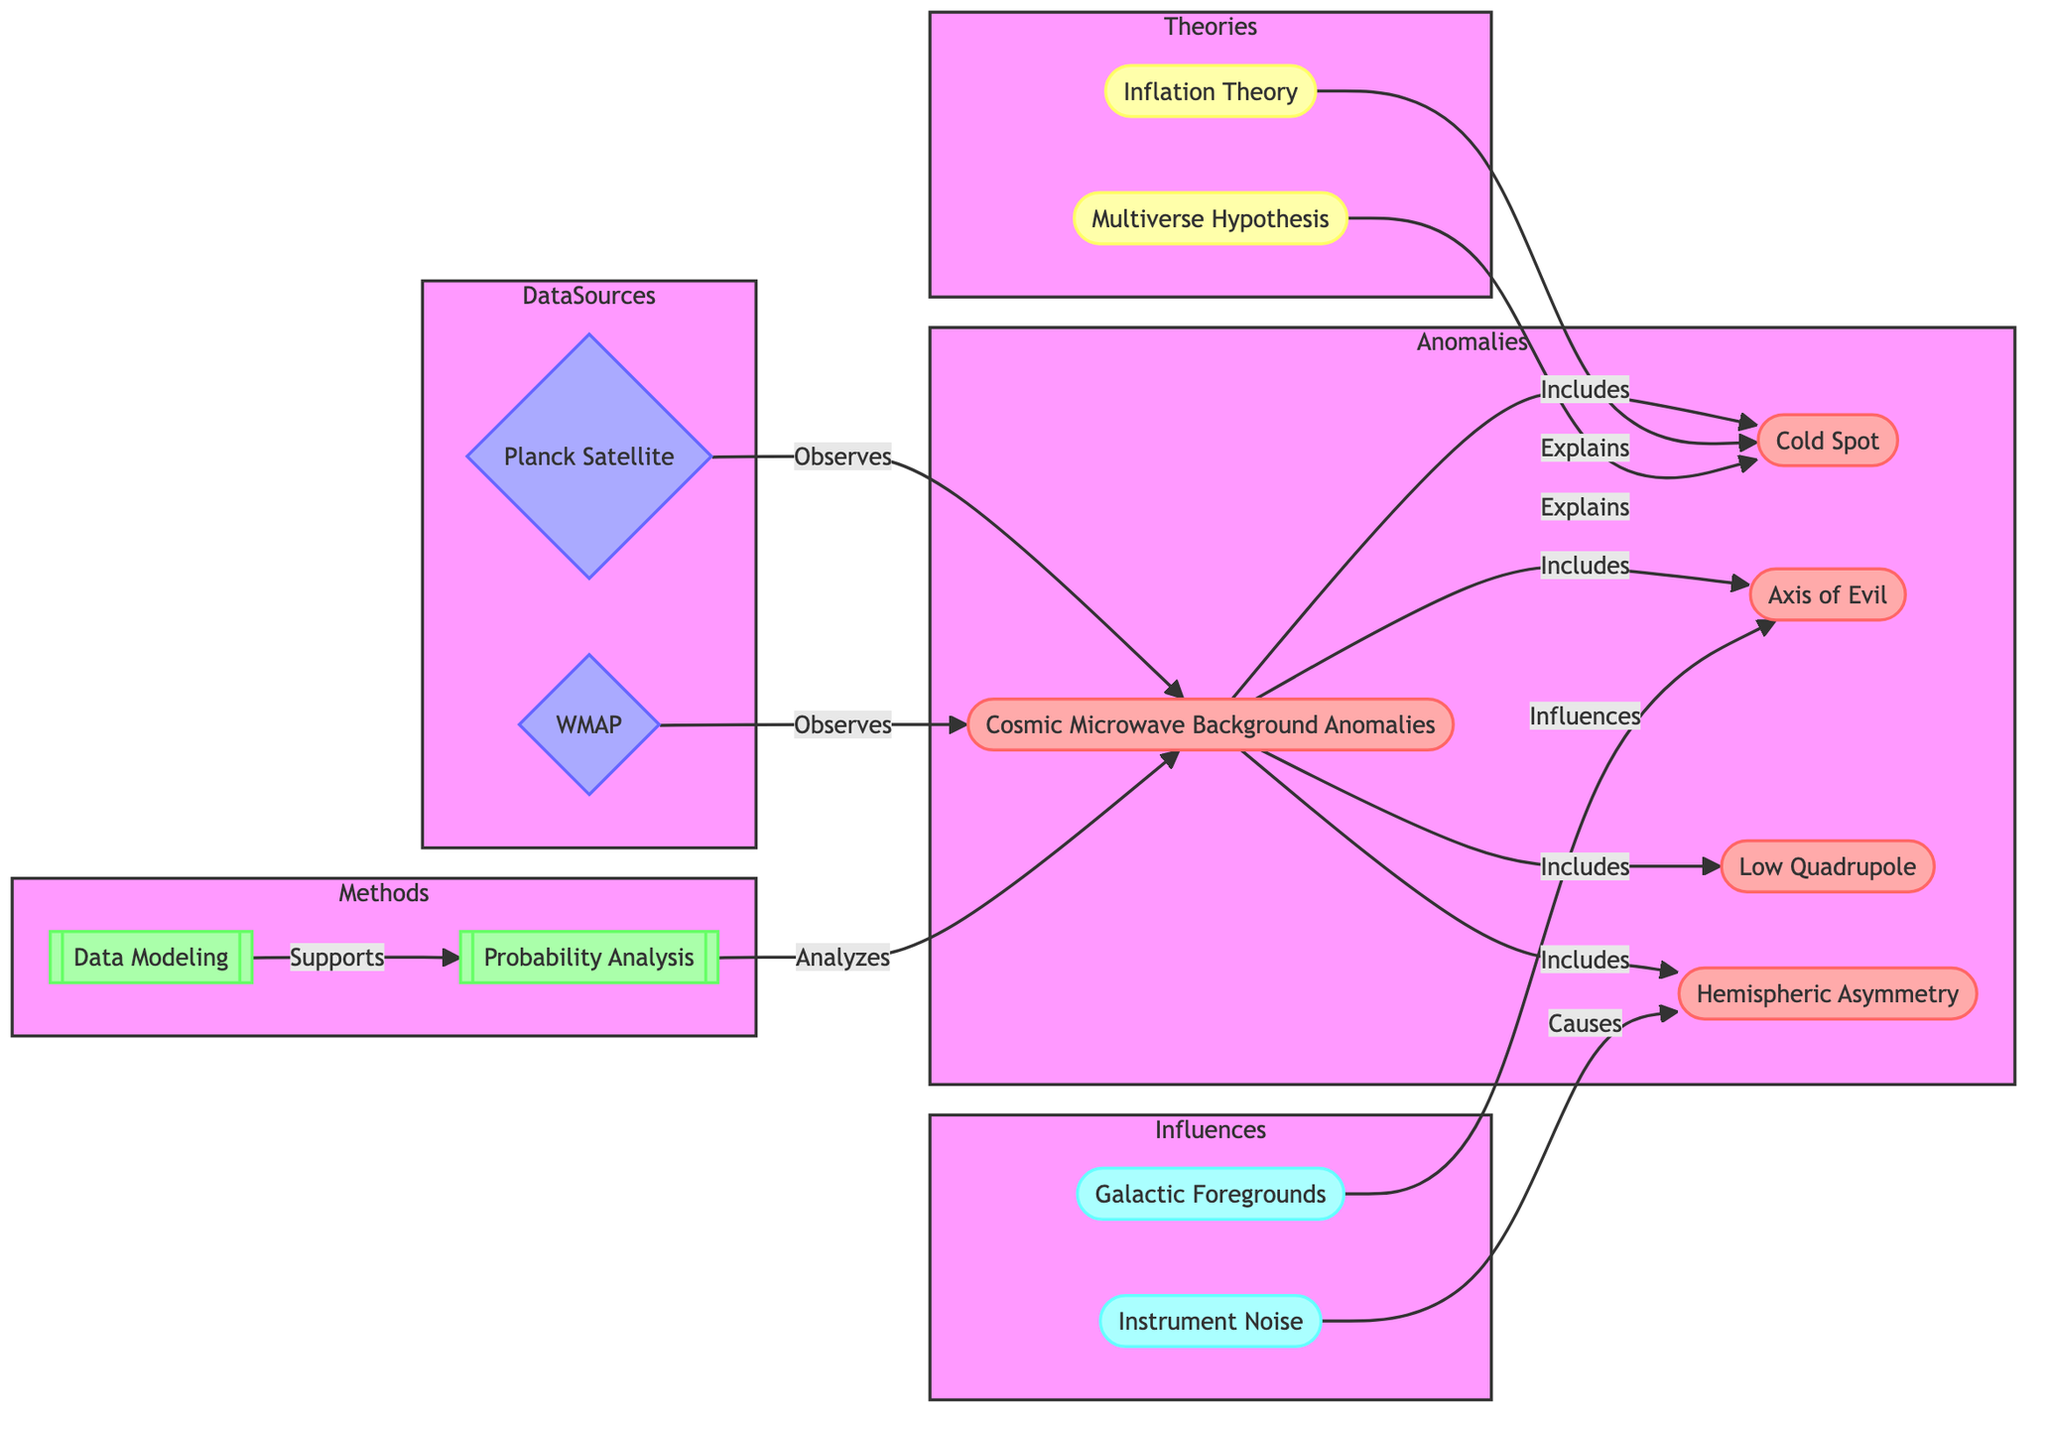What is the total number of nodes in the diagram? The diagram has various entities representing different aspects of Cosmic Microwave Background Anomalies, including anomalies, data sources, methods, theories, and influences. Upon counting, there are 12 nodes in total.
Answer: 12 How many edges are connected to "CMB Anomalies"? The "CMB Anomalies" node has several connections that represent its relationships with other nodes. By examining the diagram, it can be seen that "CMB Anomalies" has 4 direct connections (to "Cold Spot," "Axis of Evil," "Low Quadrupole," and "Hemispheric Asymmetry").
Answer: 4 Which theories explain the "Cold Spot"? The diagram shows that both "Inflation Theory" and "Multiverse Hypothesis" are linked to and explain the "Cold Spot." This can be confirmed by looking at the directed edges leading from these theories to the "Cold Spot."
Answer: Inflation Theory, Multiverse Hypothesis What influences the "Axis of Evil"? In the diagram, "Galactic Foregrounds" is indicated to have a direct influence on the "Axis of Evil," which can be seen through the connecting edge labeled "Influences."
Answer: Galactic Foregrounds Which method supports "Probability Analysis"? The diagram indicates that "Data Modeling" directly supports "Probability Analysis." This relationship can be confirmed by the directed edge labeled "Supports" leading from "Data Modeling" to "Probability Analysis."
Answer: Data Modeling What is the relationship between "Instrument Noise" and "Hemispheric Asymmetry"? The edge from "Instrument Noise" to "Hemispheric Asymmetry" is labeled "Causes," indicating that the relationship represents a causal connection where instrument noise affects hemispheric asymmetry.
Answer: Causes How many data sources are depicted in the diagram? The diagram includes two data sources: "Planck Satellite" and "WMAP." Counting these entities confirms that there are exactly two data sources represented.
Answer: 2 Which anomaly is included under "CMB Anomalies" but is not explained by any theories? The "Low Quadrupole" anomaly is depicted as being included under "CMB Anomalies," but there are no edges connecting it to any of the theories presented in the diagram.
Answer: Low Quadrupole What nodes are connected to "Probability Analysis"? The "Probability Analysis" node is connected to "CMB Anomalies" via the edge labeled "Analyzes," and it receives support from "Data Modeling." When evaluating the edges, it shows a relationship with both those nodes.
Answer: CMB Anomalies, Data Modeling 